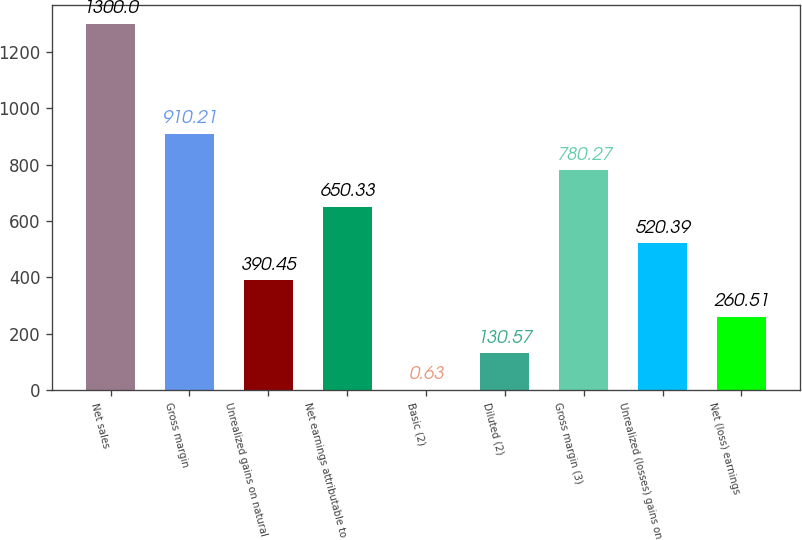<chart> <loc_0><loc_0><loc_500><loc_500><bar_chart><fcel>Net sales<fcel>Gross margin<fcel>Unrealized gains on natural<fcel>Net earnings attributable to<fcel>Basic (2)<fcel>Diluted (2)<fcel>Gross margin (3)<fcel>Unrealized (losses) gains on<fcel>Net (loss) earnings<nl><fcel>1300<fcel>910.21<fcel>390.45<fcel>650.33<fcel>0.63<fcel>130.57<fcel>780.27<fcel>520.39<fcel>260.51<nl></chart> 